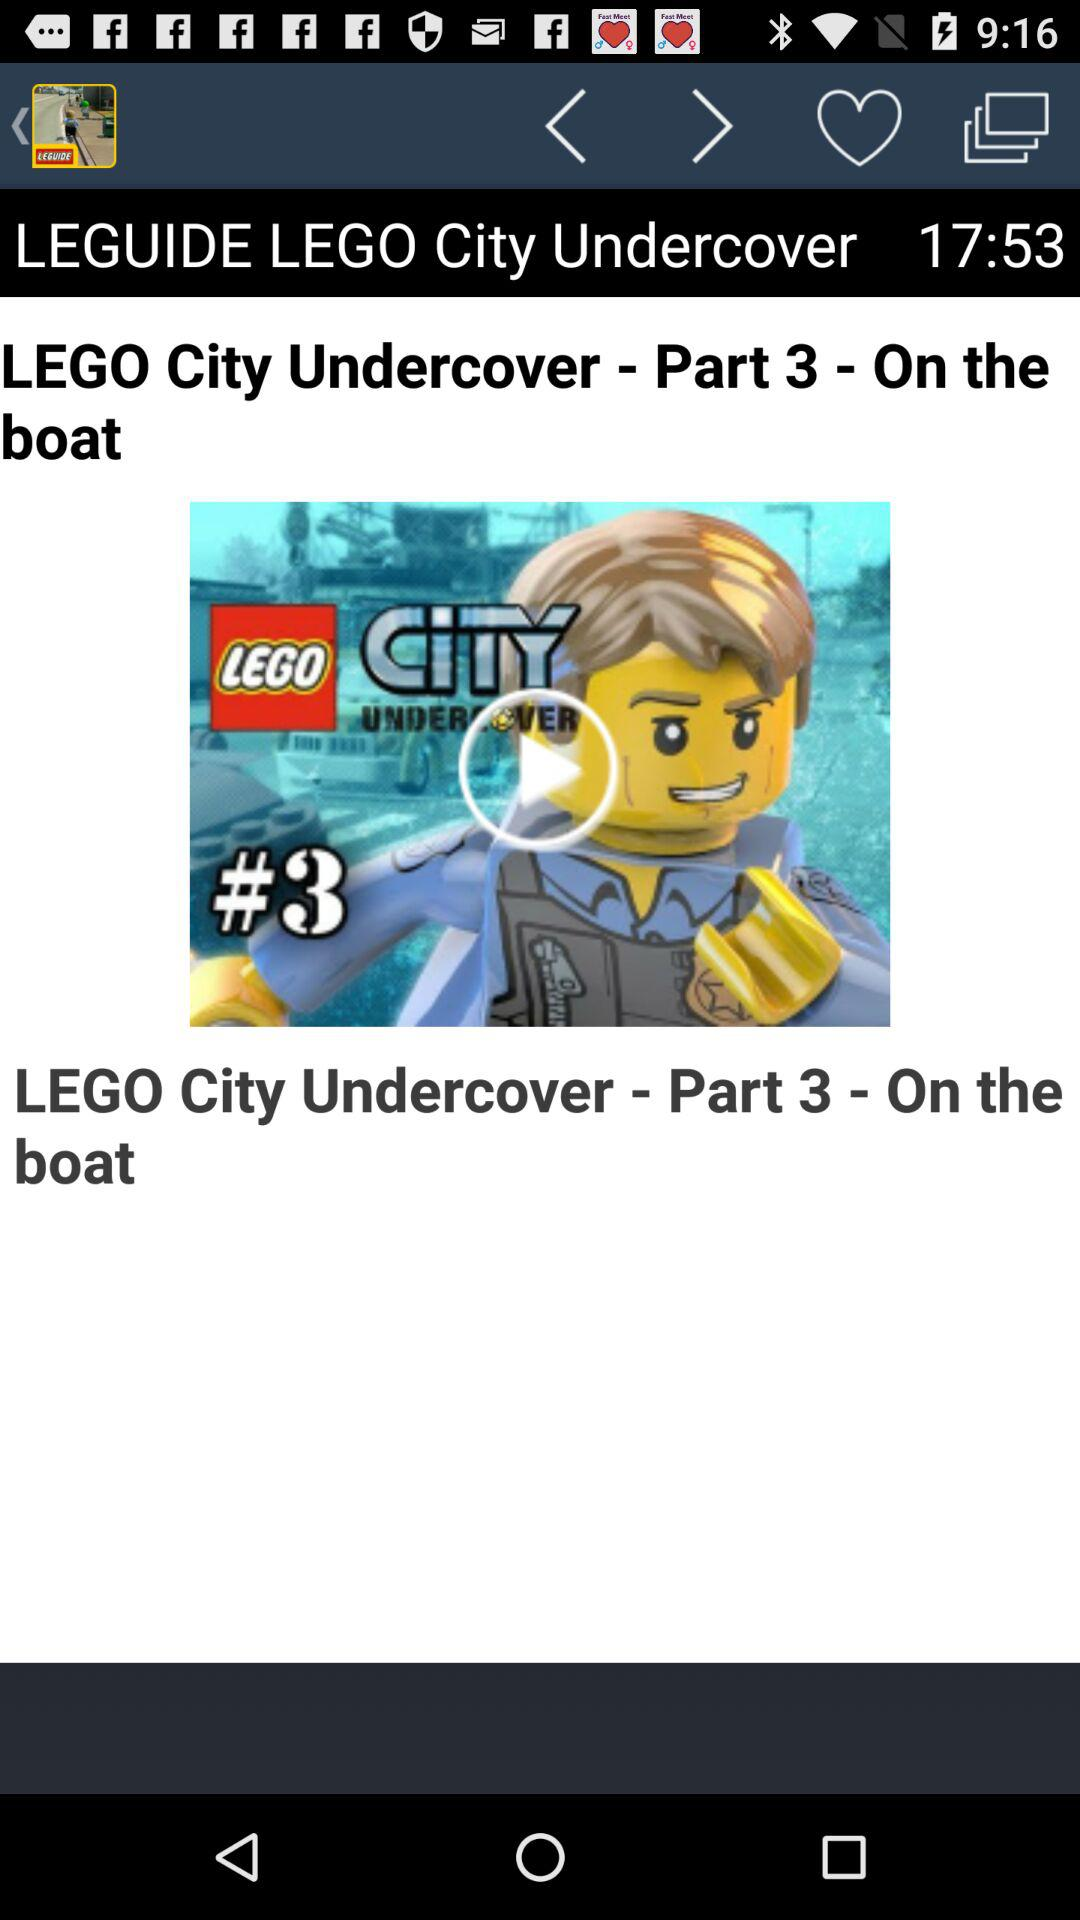What is the video's name? The video's name is "LEGO City Undercover - Part 3 - On the boat". 